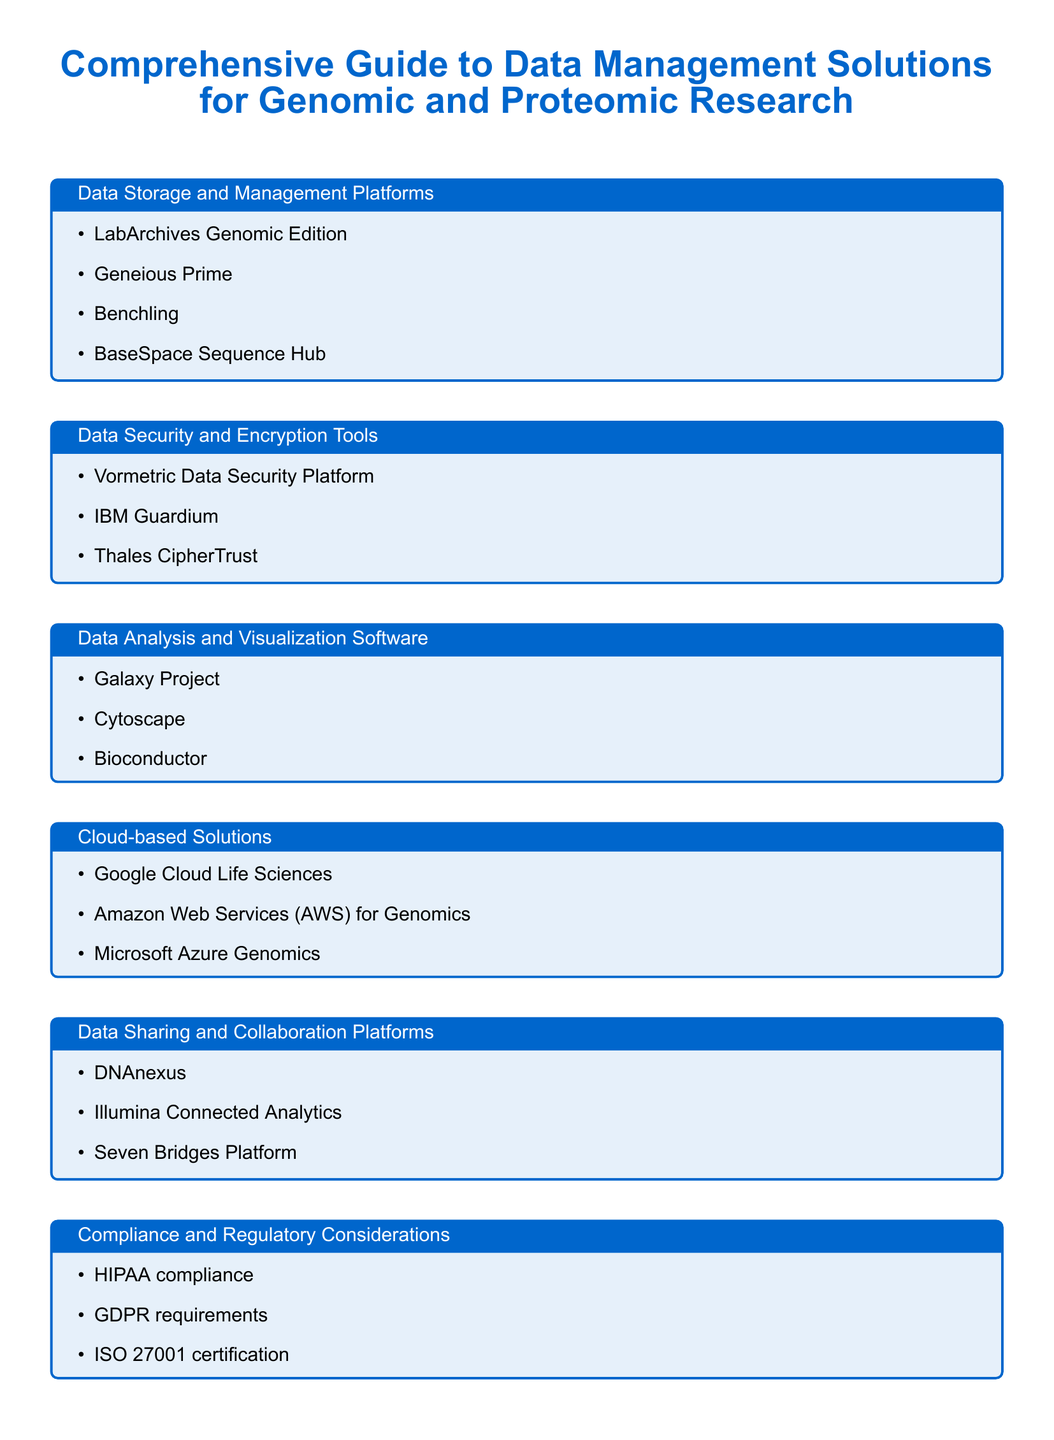what is the title of the document? The title is presented in the document's header and describes the content focusing on data management for specific types of research.
Answer: Comprehensive Guide to Data Management Solutions for Genomic and Proteomic Research how many data storage platforms are listed? The document lists various data storage and management platforms under a specific section.
Answer: Four name one data security tool mentioned in the document. The document includes a section dedicated to data security and encryption tools, listing specific products.
Answer: Vormetric Data Security Platform which cloud-based solution is mentioned first? The cloud-based solutions are organized in a specific order, with the first one listed being significant.
Answer: Google Cloud Life Sciences what does HIPAA compliance relate to? HIPAA compliance is included under a section regarding compliance and regulatory considerations, indicating a focus on data protection in healthcare.
Answer: Compliance which software is listed under data analysis and visualization? The document provides examples of software tools designed to analyze and visualize data specifically for genomic and proteomic research.
Answer: Galaxy Project how many compliance considerations are mentioned? The document lists several compliance and regulatory considerations relevant to data management in research contexts.
Answer: Three what type of document is this? The document is designed as a guide, providing an overview of data management solutions tailored for a specific research field.
Answer: Guide 